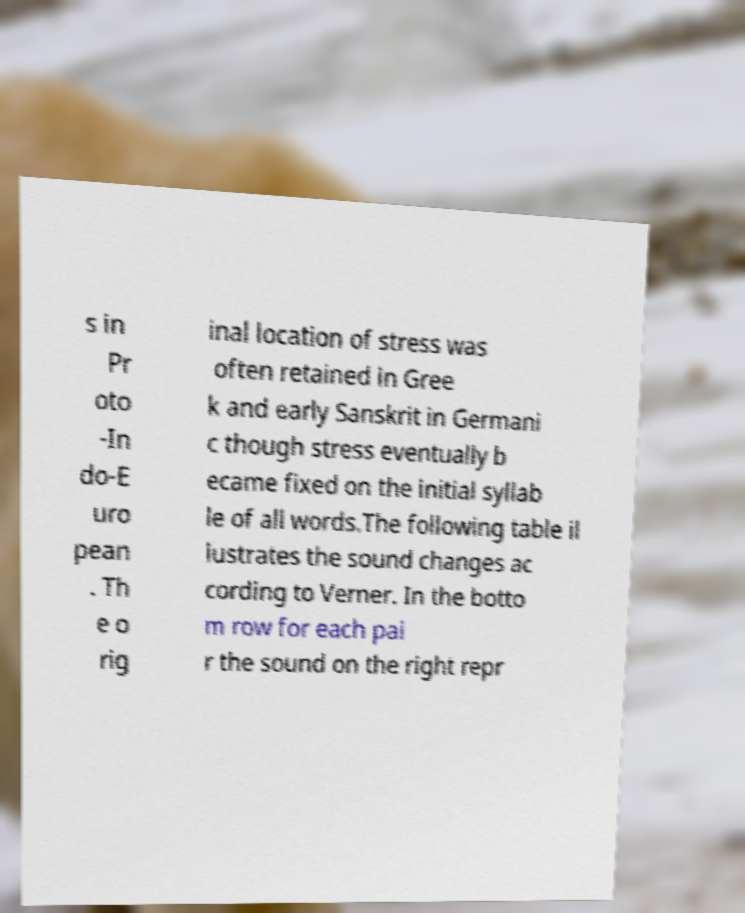Please read and relay the text visible in this image. What does it say? s in Pr oto -In do-E uro pean . Th e o rig inal location of stress was often retained in Gree k and early Sanskrit in Germani c though stress eventually b ecame fixed on the initial syllab le of all words.The following table il lustrates the sound changes ac cording to Verner. In the botto m row for each pai r the sound on the right repr 